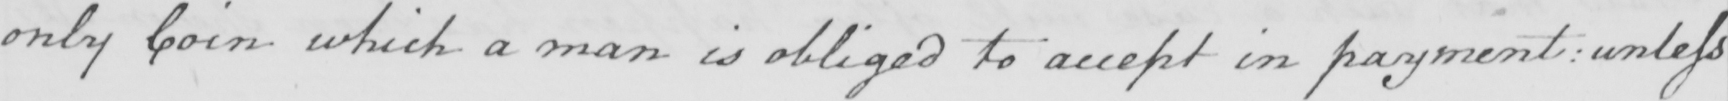What text is written in this handwritten line? only Coin which a man is obliged to accept in payment  :  unless 